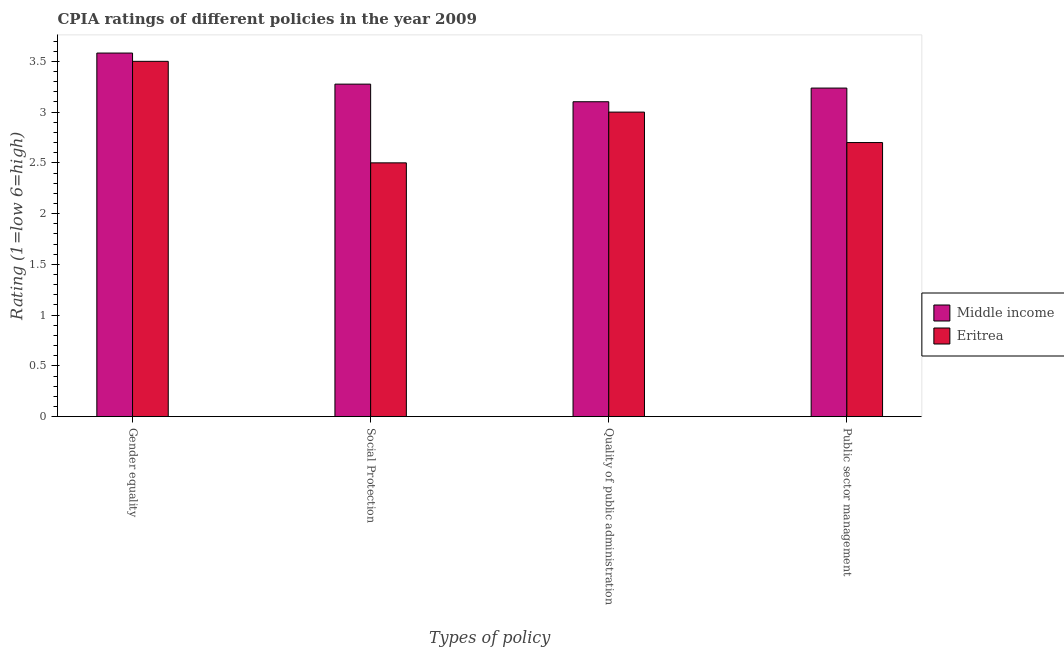Are the number of bars per tick equal to the number of legend labels?
Offer a terse response. Yes. Are the number of bars on each tick of the X-axis equal?
Give a very brief answer. Yes. How many bars are there on the 2nd tick from the left?
Ensure brevity in your answer.  2. How many bars are there on the 4th tick from the right?
Provide a succinct answer. 2. What is the label of the 1st group of bars from the left?
Your answer should be compact. Gender equality. What is the cpia rating of social protection in Eritrea?
Ensure brevity in your answer.  2.5. Across all countries, what is the maximum cpia rating of public sector management?
Keep it short and to the point. 3.24. In which country was the cpia rating of quality of public administration maximum?
Give a very brief answer. Middle income. In which country was the cpia rating of social protection minimum?
Provide a succinct answer. Eritrea. What is the total cpia rating of gender equality in the graph?
Give a very brief answer. 7.08. What is the difference between the cpia rating of gender equality in Eritrea and that in Middle income?
Provide a succinct answer. -0.08. What is the difference between the cpia rating of public sector management in Eritrea and the cpia rating of gender equality in Middle income?
Make the answer very short. -0.88. What is the average cpia rating of social protection per country?
Your response must be concise. 2.89. What is the difference between the cpia rating of social protection and cpia rating of public sector management in Middle income?
Offer a very short reply. 0.04. In how many countries, is the cpia rating of quality of public administration greater than 2.1 ?
Your answer should be very brief. 2. What is the ratio of the cpia rating of quality of public administration in Eritrea to that in Middle income?
Provide a short and direct response. 0.97. What is the difference between the highest and the second highest cpia rating of gender equality?
Provide a short and direct response. 0.08. What is the difference between the highest and the lowest cpia rating of public sector management?
Provide a short and direct response. 0.54. In how many countries, is the cpia rating of public sector management greater than the average cpia rating of public sector management taken over all countries?
Offer a very short reply. 1. Is the sum of the cpia rating of public sector management in Eritrea and Middle income greater than the maximum cpia rating of social protection across all countries?
Ensure brevity in your answer.  Yes. How many countries are there in the graph?
Give a very brief answer. 2. What is the difference between two consecutive major ticks on the Y-axis?
Provide a succinct answer. 0.5. Does the graph contain any zero values?
Make the answer very short. No. Does the graph contain grids?
Offer a terse response. No. How many legend labels are there?
Provide a short and direct response. 2. What is the title of the graph?
Provide a succinct answer. CPIA ratings of different policies in the year 2009. Does "Sudan" appear as one of the legend labels in the graph?
Keep it short and to the point. No. What is the label or title of the X-axis?
Your answer should be compact. Types of policy. What is the Rating (1=low 6=high) of Middle income in Gender equality?
Keep it short and to the point. 3.58. What is the Rating (1=low 6=high) of Eritrea in Gender equality?
Offer a very short reply. 3.5. What is the Rating (1=low 6=high) in Middle income in Social Protection?
Your response must be concise. 3.28. What is the Rating (1=low 6=high) in Eritrea in Social Protection?
Provide a succinct answer. 2.5. What is the Rating (1=low 6=high) in Middle income in Quality of public administration?
Offer a very short reply. 3.1. What is the Rating (1=low 6=high) of Middle income in Public sector management?
Ensure brevity in your answer.  3.24. Across all Types of policy, what is the maximum Rating (1=low 6=high) in Middle income?
Your answer should be very brief. 3.58. Across all Types of policy, what is the minimum Rating (1=low 6=high) of Middle income?
Provide a succinct answer. 3.1. Across all Types of policy, what is the minimum Rating (1=low 6=high) of Eritrea?
Your response must be concise. 2.5. What is the total Rating (1=low 6=high) of Middle income in the graph?
Your response must be concise. 13.2. What is the difference between the Rating (1=low 6=high) of Middle income in Gender equality and that in Social Protection?
Provide a short and direct response. 0.31. What is the difference between the Rating (1=low 6=high) in Eritrea in Gender equality and that in Social Protection?
Your answer should be compact. 1. What is the difference between the Rating (1=low 6=high) of Middle income in Gender equality and that in Quality of public administration?
Offer a terse response. 0.48. What is the difference between the Rating (1=low 6=high) in Middle income in Gender equality and that in Public sector management?
Keep it short and to the point. 0.34. What is the difference between the Rating (1=low 6=high) of Middle income in Social Protection and that in Quality of public administration?
Provide a succinct answer. 0.17. What is the difference between the Rating (1=low 6=high) of Eritrea in Social Protection and that in Quality of public administration?
Provide a short and direct response. -0.5. What is the difference between the Rating (1=low 6=high) in Middle income in Social Protection and that in Public sector management?
Your answer should be very brief. 0.04. What is the difference between the Rating (1=low 6=high) of Middle income in Quality of public administration and that in Public sector management?
Provide a short and direct response. -0.13. What is the difference between the Rating (1=low 6=high) in Middle income in Gender equality and the Rating (1=low 6=high) in Eritrea in Social Protection?
Your answer should be compact. 1.08. What is the difference between the Rating (1=low 6=high) in Middle income in Gender equality and the Rating (1=low 6=high) in Eritrea in Quality of public administration?
Your response must be concise. 0.58. What is the difference between the Rating (1=low 6=high) in Middle income in Gender equality and the Rating (1=low 6=high) in Eritrea in Public sector management?
Offer a very short reply. 0.88. What is the difference between the Rating (1=low 6=high) in Middle income in Social Protection and the Rating (1=low 6=high) in Eritrea in Quality of public administration?
Provide a succinct answer. 0.28. What is the difference between the Rating (1=low 6=high) in Middle income in Social Protection and the Rating (1=low 6=high) in Eritrea in Public sector management?
Give a very brief answer. 0.58. What is the difference between the Rating (1=low 6=high) of Middle income in Quality of public administration and the Rating (1=low 6=high) of Eritrea in Public sector management?
Provide a short and direct response. 0.4. What is the average Rating (1=low 6=high) in Middle income per Types of policy?
Your answer should be very brief. 3.3. What is the average Rating (1=low 6=high) of Eritrea per Types of policy?
Your answer should be compact. 2.92. What is the difference between the Rating (1=low 6=high) of Middle income and Rating (1=low 6=high) of Eritrea in Gender equality?
Make the answer very short. 0.08. What is the difference between the Rating (1=low 6=high) of Middle income and Rating (1=low 6=high) of Eritrea in Social Protection?
Keep it short and to the point. 0.78. What is the difference between the Rating (1=low 6=high) in Middle income and Rating (1=low 6=high) in Eritrea in Quality of public administration?
Provide a succinct answer. 0.1. What is the difference between the Rating (1=low 6=high) of Middle income and Rating (1=low 6=high) of Eritrea in Public sector management?
Offer a terse response. 0.54. What is the ratio of the Rating (1=low 6=high) in Middle income in Gender equality to that in Social Protection?
Provide a short and direct response. 1.09. What is the ratio of the Rating (1=low 6=high) of Middle income in Gender equality to that in Quality of public administration?
Ensure brevity in your answer.  1.15. What is the ratio of the Rating (1=low 6=high) in Middle income in Gender equality to that in Public sector management?
Offer a very short reply. 1.11. What is the ratio of the Rating (1=low 6=high) of Eritrea in Gender equality to that in Public sector management?
Give a very brief answer. 1.3. What is the ratio of the Rating (1=low 6=high) of Middle income in Social Protection to that in Quality of public administration?
Your answer should be very brief. 1.06. What is the ratio of the Rating (1=low 6=high) in Eritrea in Social Protection to that in Quality of public administration?
Offer a very short reply. 0.83. What is the ratio of the Rating (1=low 6=high) of Middle income in Social Protection to that in Public sector management?
Make the answer very short. 1.01. What is the ratio of the Rating (1=low 6=high) of Eritrea in Social Protection to that in Public sector management?
Provide a short and direct response. 0.93. What is the ratio of the Rating (1=low 6=high) of Middle income in Quality of public administration to that in Public sector management?
Your answer should be compact. 0.96. What is the difference between the highest and the second highest Rating (1=low 6=high) in Middle income?
Your response must be concise. 0.31. What is the difference between the highest and the lowest Rating (1=low 6=high) of Middle income?
Ensure brevity in your answer.  0.48. What is the difference between the highest and the lowest Rating (1=low 6=high) in Eritrea?
Provide a succinct answer. 1. 